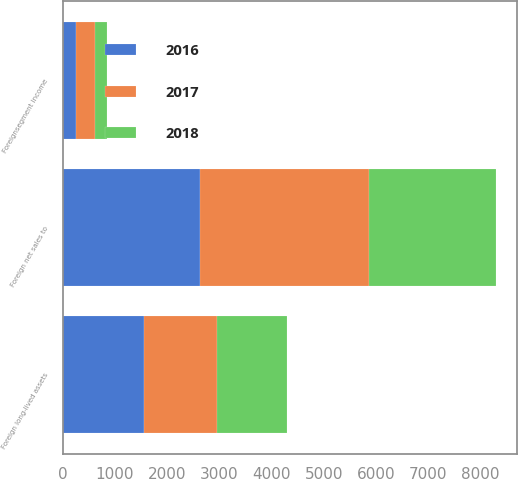Convert chart to OTSL. <chart><loc_0><loc_0><loc_500><loc_500><stacked_bar_chart><ecel><fcel>Foreign net sales to<fcel>Foreignsegment income<fcel>Foreign long-lived assets<nl><fcel>2017<fcel>3236.7<fcel>360.7<fcel>1400.2<nl><fcel>2016<fcel>2621.2<fcel>260.1<fcel>1558.3<nl><fcel>2018<fcel>2426.6<fcel>226.1<fcel>1341.5<nl></chart> 